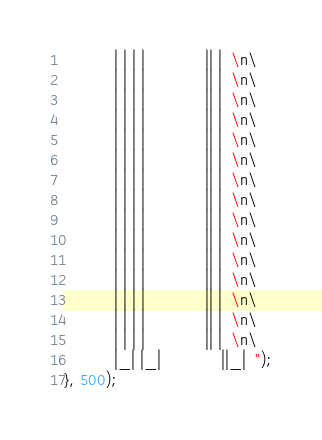<code> <loc_0><loc_0><loc_500><loc_500><_JavaScript_>	       | | | |             || |  \n\
	       | | | |             || |  \n\
	       | | | |             || |  \n\
	       | | | |             || |  \n\
	       | | | |             || |  \n\
	       | | | |             || |  \n\
	       | | | |             || |  \n\
	       | | | |             || |  \n\
	       | | | |             || |  \n\
	       | | | |             || |  \n\
	       | | | |             || |  \n\
	       | | | |             || |  \n\
	       | | | |             || |  \n\
	       | | | |             || |  \n\
	       | | | |             || |  \n\
	       |_| |_|             ||_|  ");
}, 500);</code> 